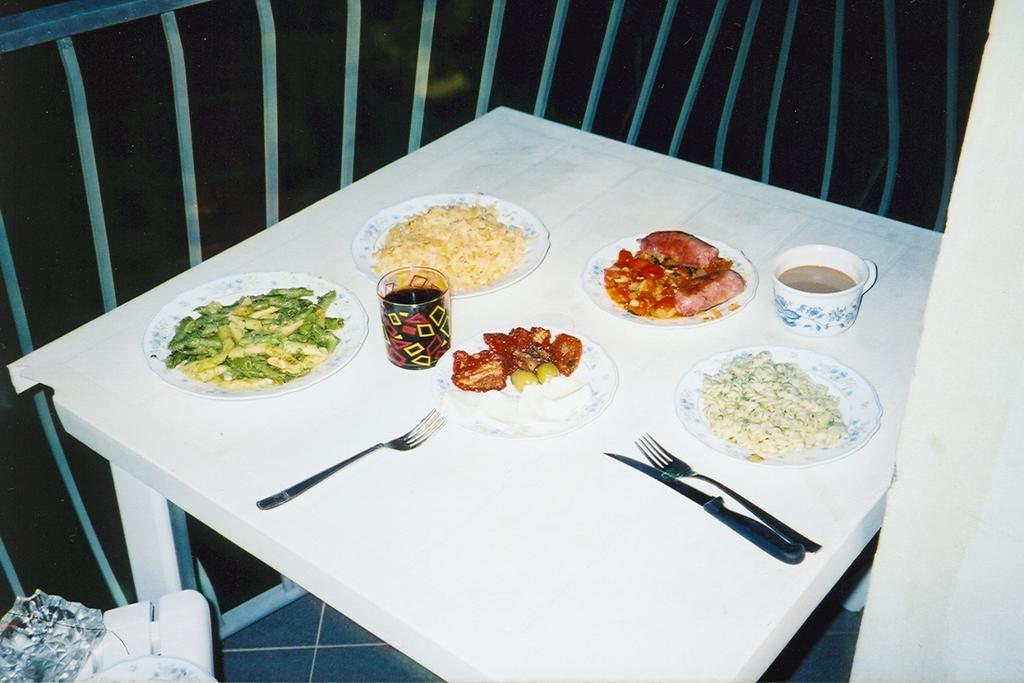What piece of furniture is present in the image? There is a table in the image. What type of food can be seen on the table? There is a plate with pasta on the table. What beverage is visible on the table? There is a cup with coffee on the table. What other food items are on the table? There are several food items on the table. What utensils are present on the table? There is a knife and a fork on the table. How does the pollution affect the trail in the image? There is no mention of pollution or a trail in the image; it features a table with food and utensils. 